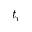<formula> <loc_0><loc_0><loc_500><loc_500>t _ { r }</formula> 